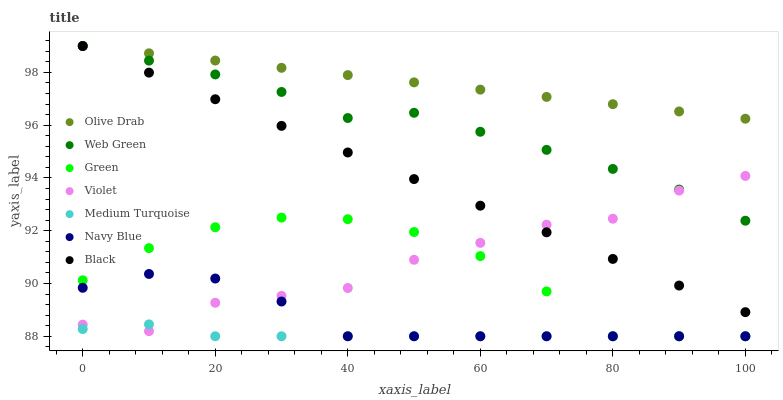Does Medium Turquoise have the minimum area under the curve?
Answer yes or no. Yes. Does Olive Drab have the maximum area under the curve?
Answer yes or no. Yes. Does Web Green have the minimum area under the curve?
Answer yes or no. No. Does Web Green have the maximum area under the curve?
Answer yes or no. No. Is Black the smoothest?
Answer yes or no. Yes. Is Violet the roughest?
Answer yes or no. Yes. Is Web Green the smoothest?
Answer yes or no. No. Is Web Green the roughest?
Answer yes or no. No. Does Navy Blue have the lowest value?
Answer yes or no. Yes. Does Web Green have the lowest value?
Answer yes or no. No. Does Olive Drab have the highest value?
Answer yes or no. Yes. Does Green have the highest value?
Answer yes or no. No. Is Green less than Web Green?
Answer yes or no. Yes. Is Web Green greater than Medium Turquoise?
Answer yes or no. Yes. Does Navy Blue intersect Green?
Answer yes or no. Yes. Is Navy Blue less than Green?
Answer yes or no. No. Is Navy Blue greater than Green?
Answer yes or no. No. Does Green intersect Web Green?
Answer yes or no. No. 